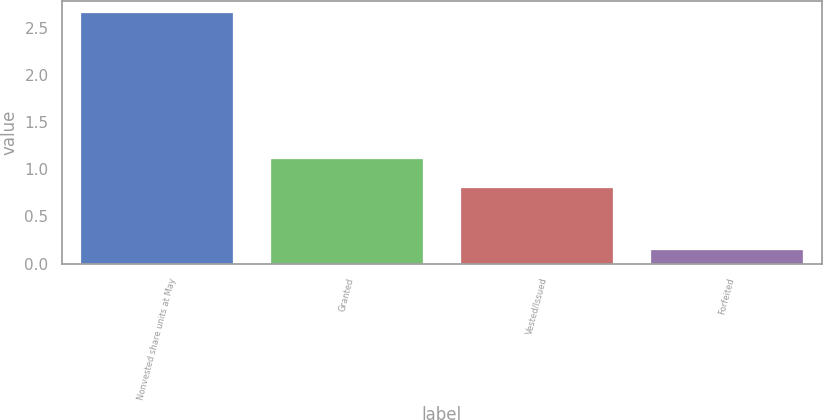Convert chart to OTSL. <chart><loc_0><loc_0><loc_500><loc_500><bar_chart><fcel>Nonvested share units at May<fcel>Granted<fcel>Vested/Issued<fcel>Forfeited<nl><fcel>2.65<fcel>1.11<fcel>0.8<fcel>0.14<nl></chart> 